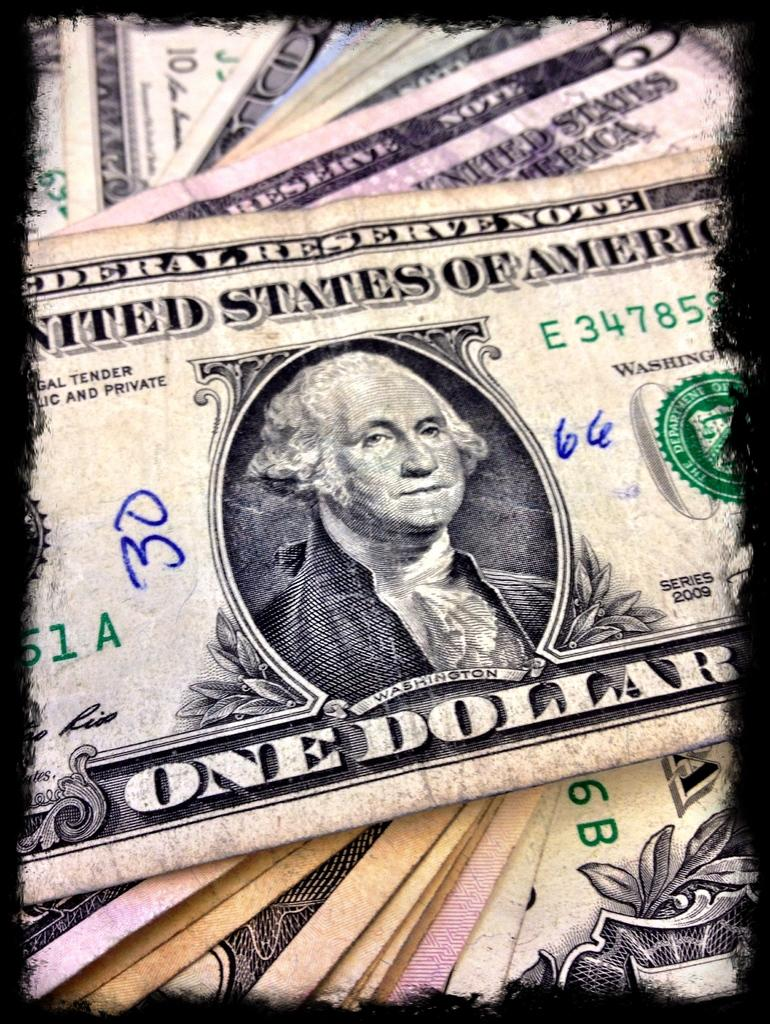What type of items are present in the image? There are currency notes in the image. What features can be observed on the currency notes? The currency notes have text and a picture on them. What type of bells can be heard ringing in the image? There are no bells present in the image, and therefore no sounds can be heard. 